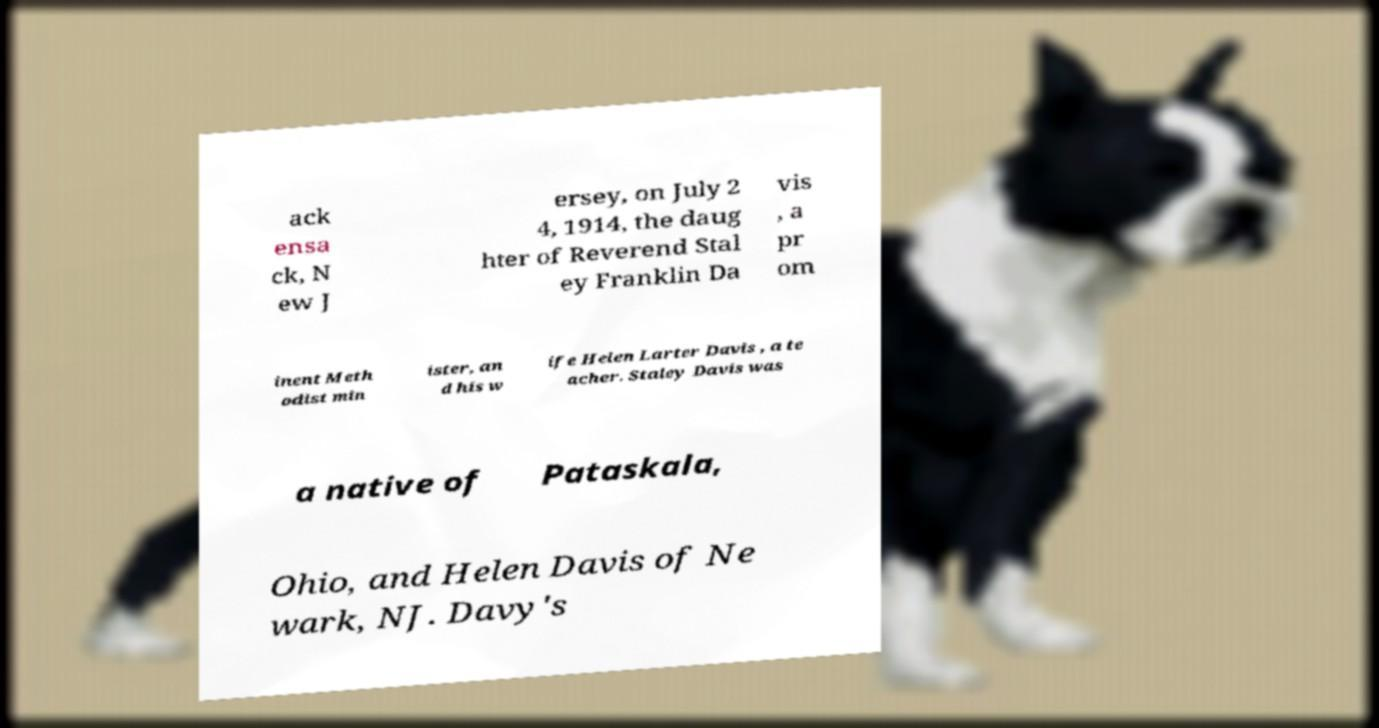Could you extract and type out the text from this image? ack ensa ck, N ew J ersey, on July 2 4, 1914, the daug hter of Reverend Stal ey Franklin Da vis , a pr om inent Meth odist min ister, an d his w ife Helen Larter Davis , a te acher. Staley Davis was a native of Pataskala, Ohio, and Helen Davis of Ne wark, NJ. Davy's 